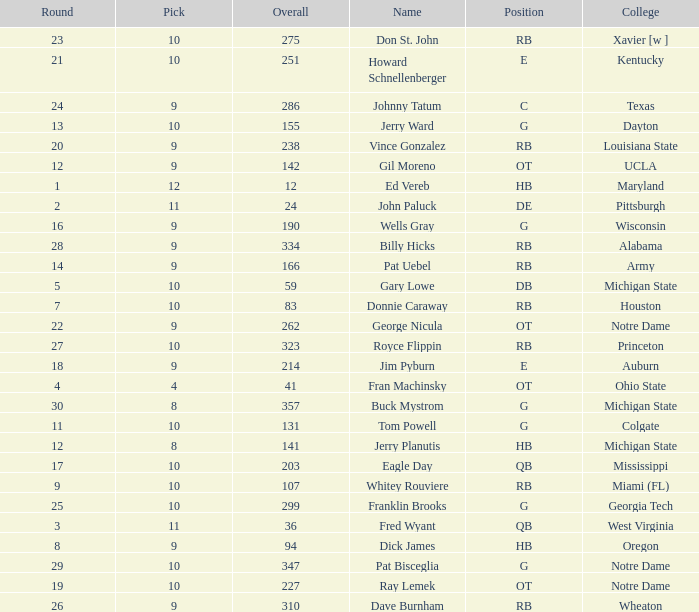What is the average number of rounds for billy hicks who had an overall pick number bigger than 310? 28.0. 